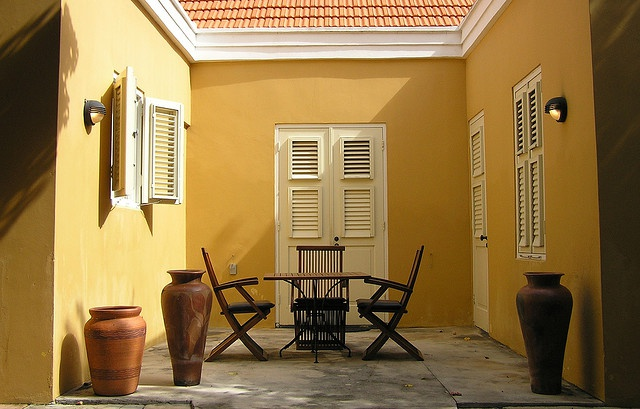Describe the objects in this image and their specific colors. I can see vase in olive, black, and maroon tones, vase in olive, maroon, and black tones, vase in olive, maroon, brown, tan, and black tones, chair in olive, black, and maroon tones, and chair in olive, black, and maroon tones in this image. 